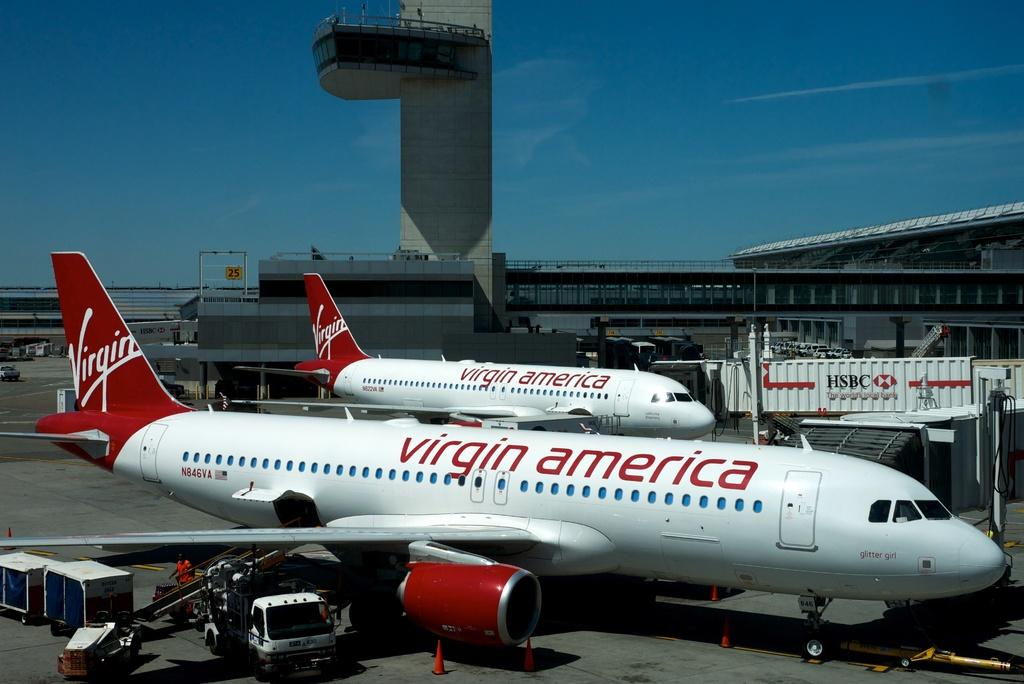<image>
Write a terse but informative summary of the picture. Two Viring American planes on the runway with a red tail. 